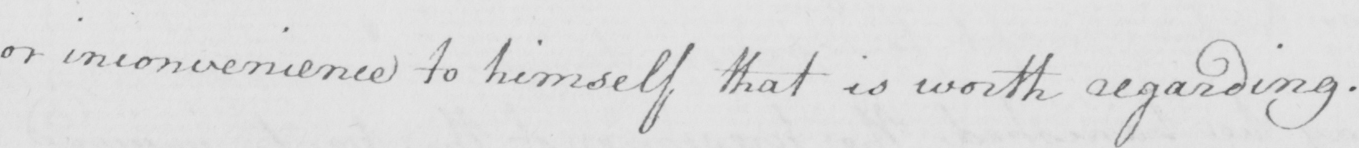Can you read and transcribe this handwriting? or inconvenience to himself that is worth regarding . 